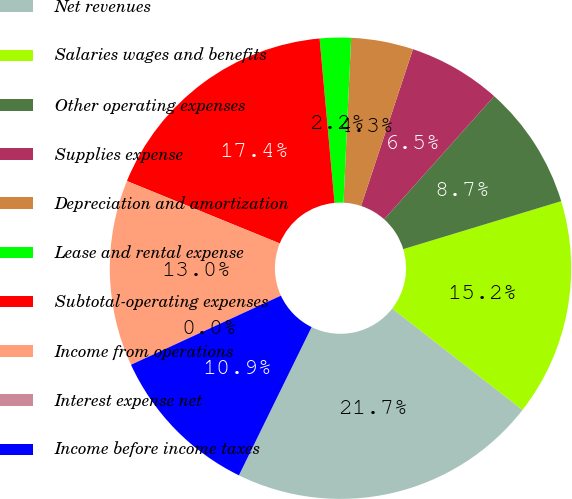Convert chart. <chart><loc_0><loc_0><loc_500><loc_500><pie_chart><fcel>Net revenues<fcel>Salaries wages and benefits<fcel>Other operating expenses<fcel>Supplies expense<fcel>Depreciation and amortization<fcel>Lease and rental expense<fcel>Subtotal-operating expenses<fcel>Income from operations<fcel>Interest expense net<fcel>Income before income taxes<nl><fcel>21.73%<fcel>15.22%<fcel>8.7%<fcel>6.52%<fcel>4.35%<fcel>2.18%<fcel>17.39%<fcel>13.04%<fcel>0.0%<fcel>10.87%<nl></chart> 